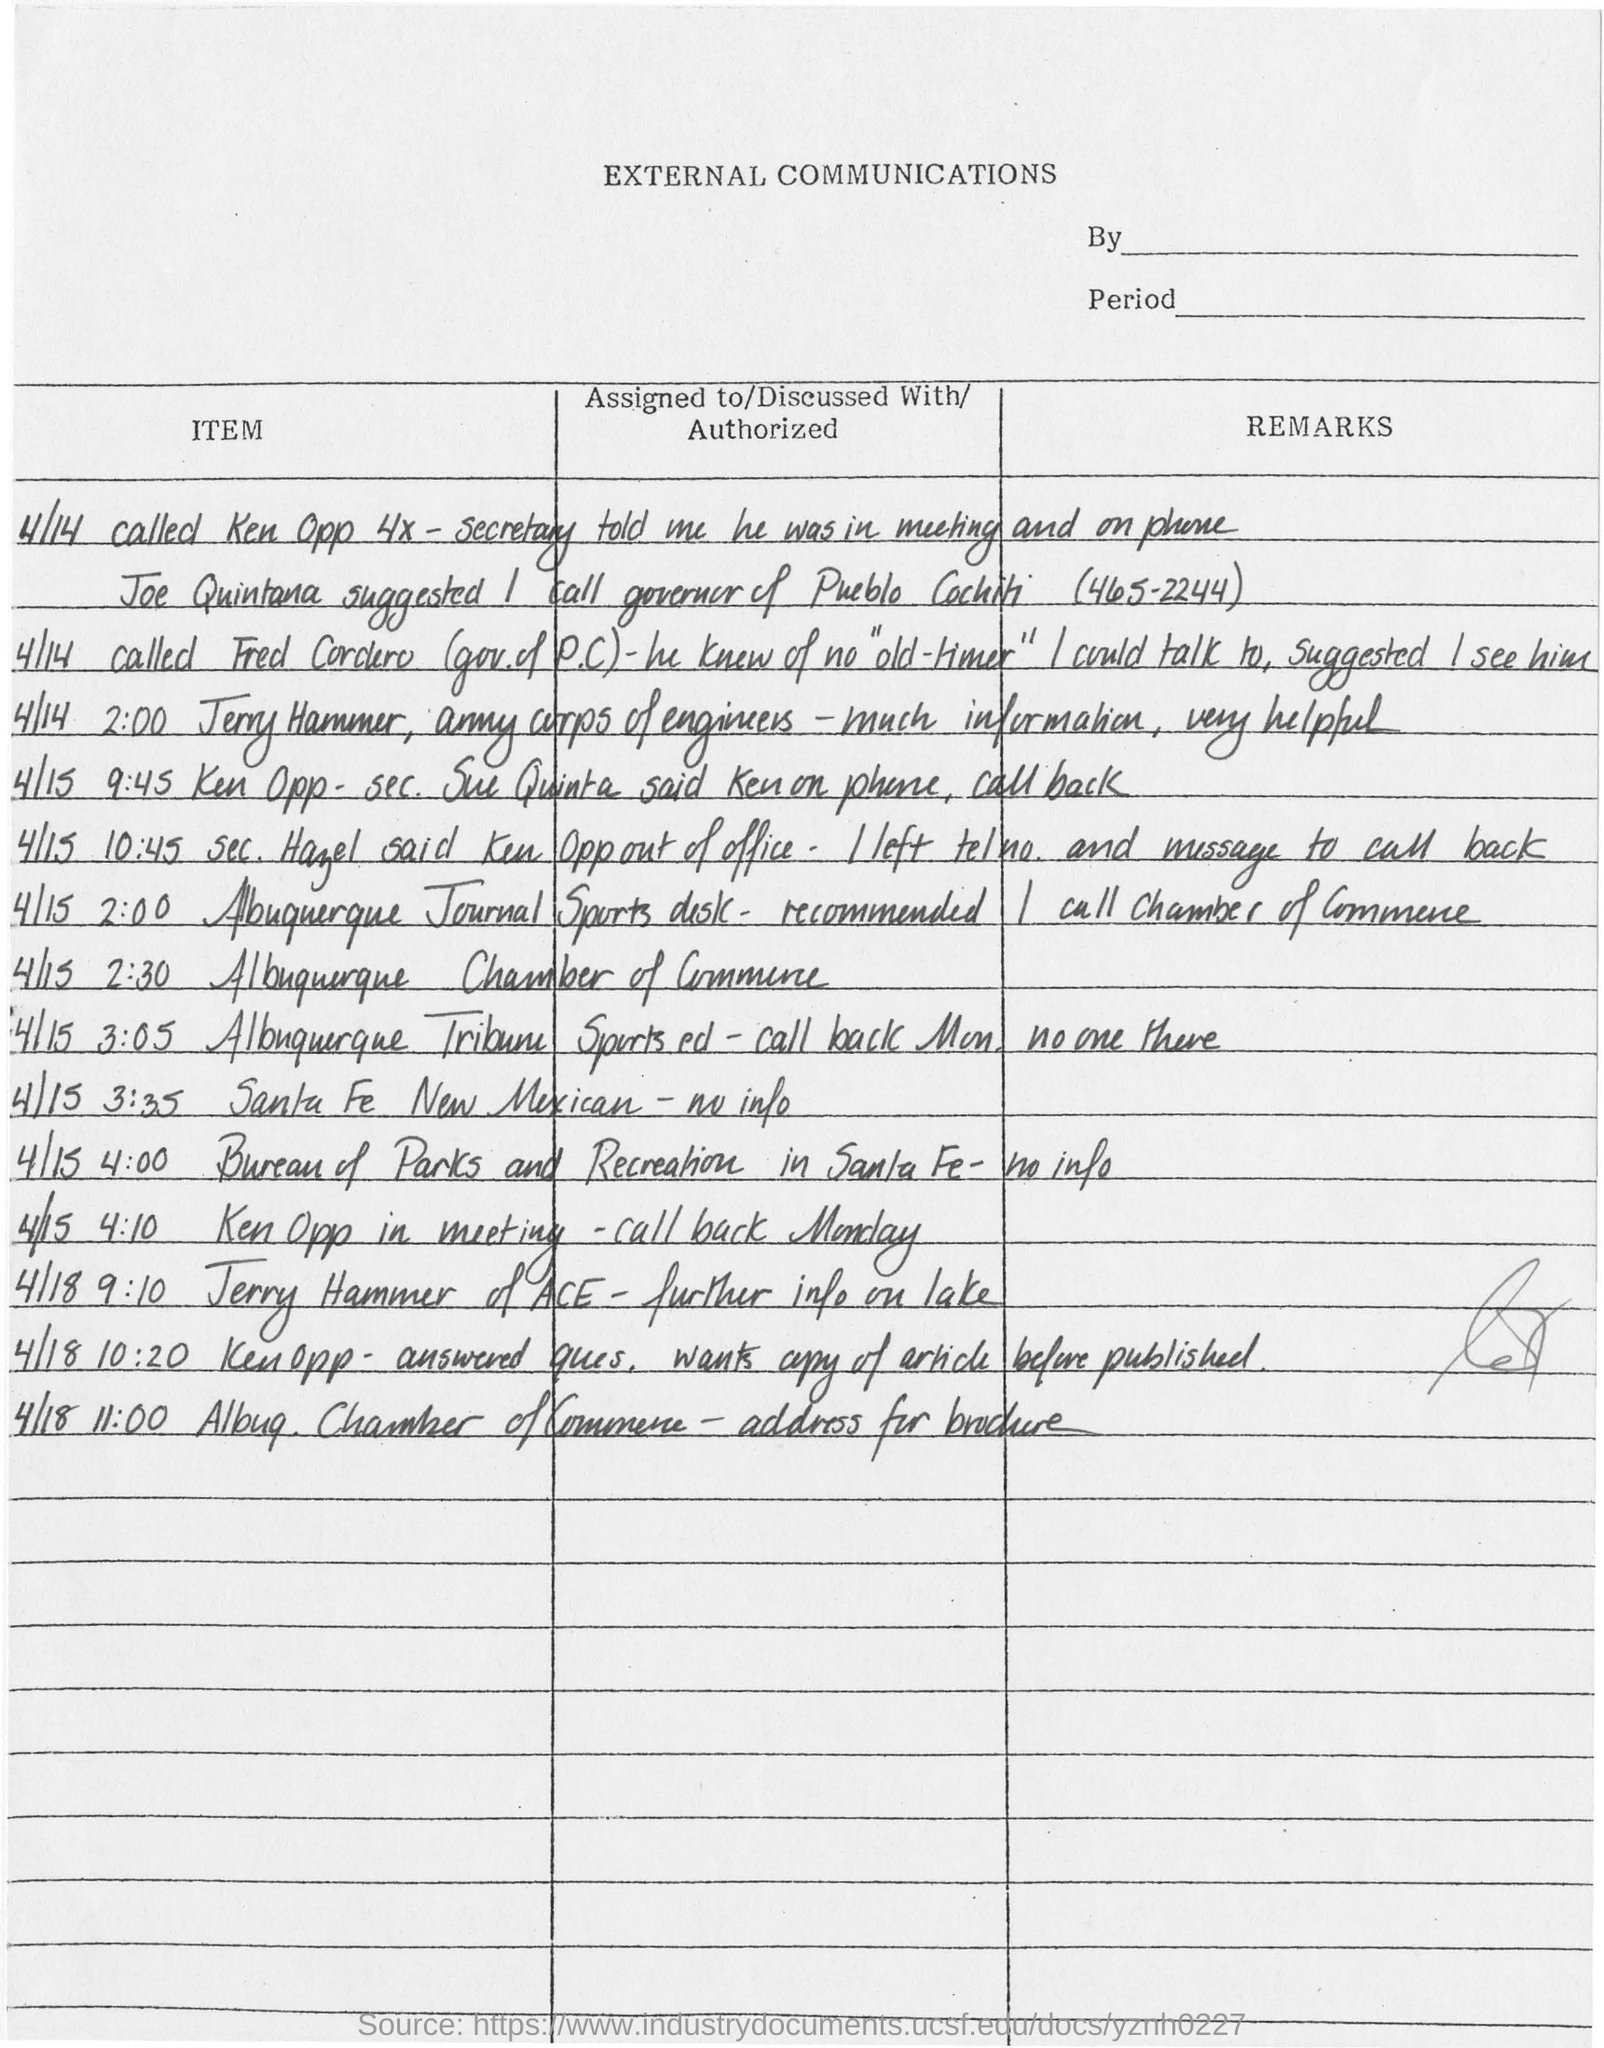What is the title of the document?
Keep it short and to the point. External Communications. 